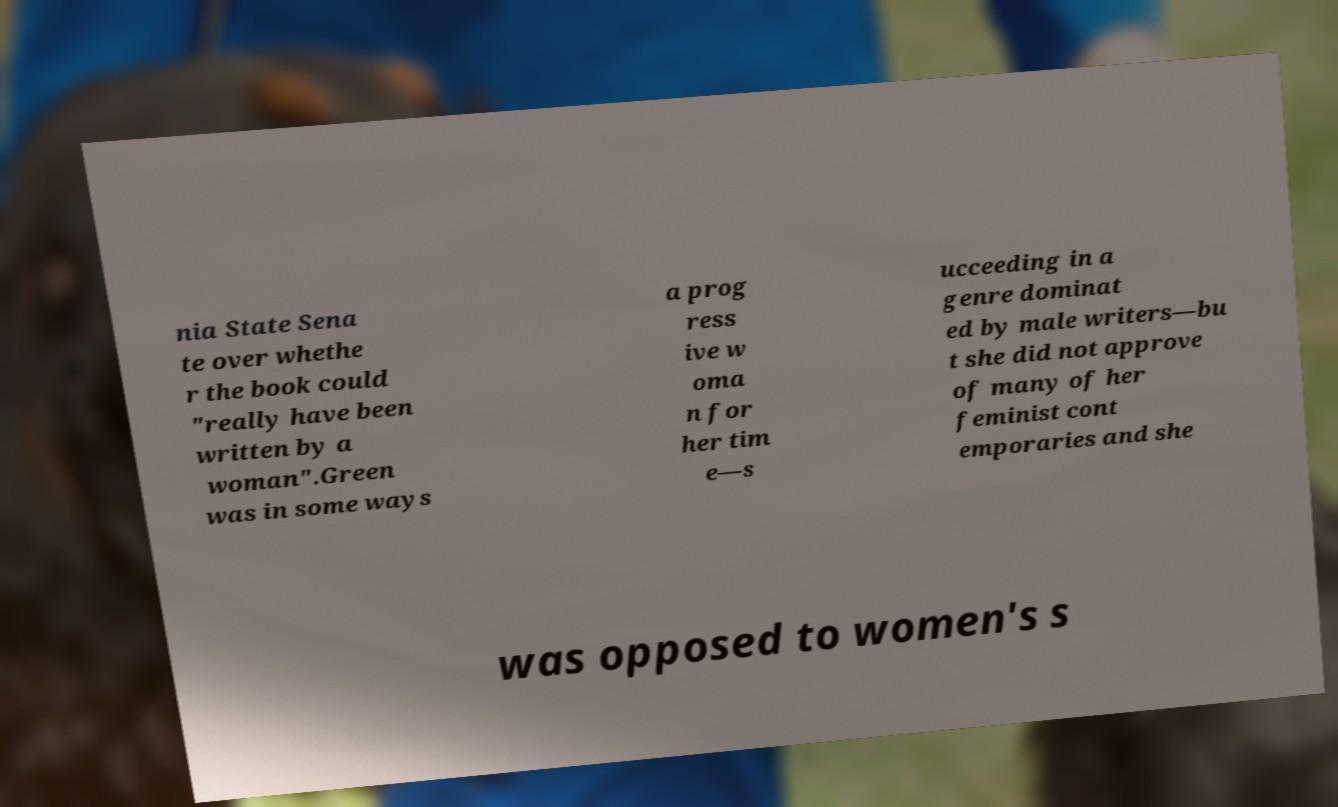For documentation purposes, I need the text within this image transcribed. Could you provide that? nia State Sena te over whethe r the book could "really have been written by a woman".Green was in some ways a prog ress ive w oma n for her tim e—s ucceeding in a genre dominat ed by male writers—bu t she did not approve of many of her feminist cont emporaries and she was opposed to women's s 